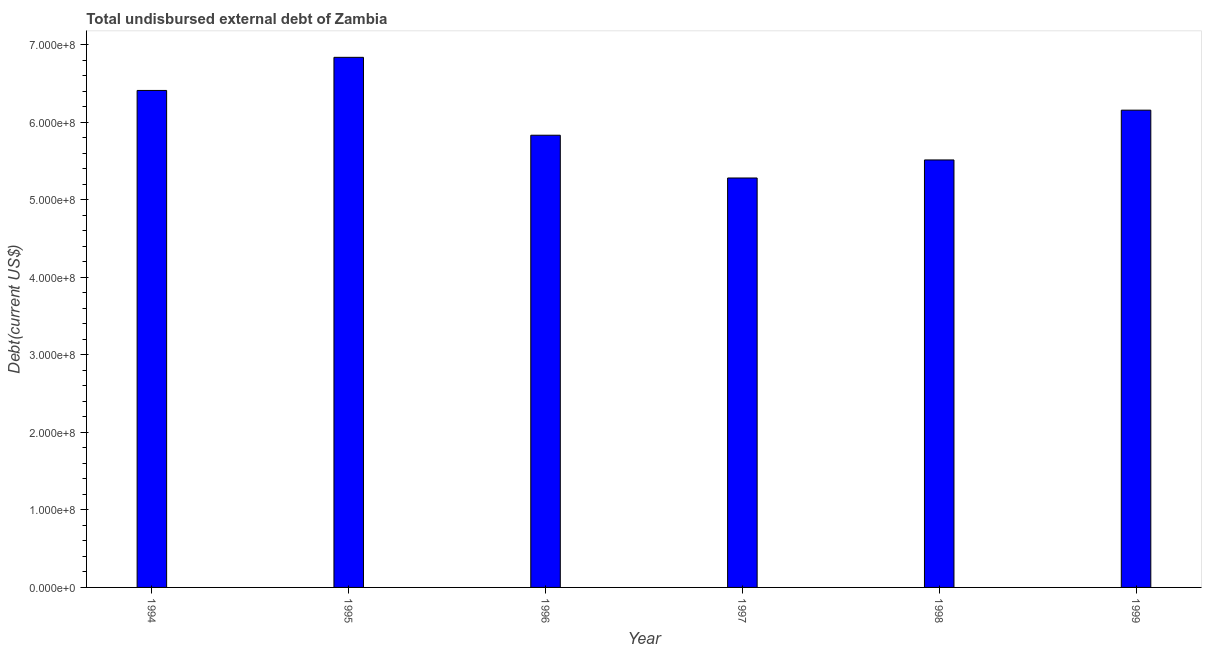Does the graph contain any zero values?
Keep it short and to the point. No. What is the title of the graph?
Make the answer very short. Total undisbursed external debt of Zambia. What is the label or title of the Y-axis?
Provide a succinct answer. Debt(current US$). What is the total debt in 1995?
Offer a very short reply. 6.84e+08. Across all years, what is the maximum total debt?
Offer a very short reply. 6.84e+08. Across all years, what is the minimum total debt?
Your response must be concise. 5.28e+08. In which year was the total debt maximum?
Ensure brevity in your answer.  1995. In which year was the total debt minimum?
Provide a short and direct response. 1997. What is the sum of the total debt?
Offer a terse response. 3.60e+09. What is the difference between the total debt in 1995 and 1998?
Provide a succinct answer. 1.32e+08. What is the average total debt per year?
Provide a succinct answer. 6.01e+08. What is the median total debt?
Your response must be concise. 6.00e+08. In how many years, is the total debt greater than 40000000 US$?
Ensure brevity in your answer.  6. What is the ratio of the total debt in 1997 to that in 1998?
Offer a terse response. 0.96. Is the total debt in 1995 less than that in 1998?
Your response must be concise. No. Is the difference between the total debt in 1995 and 1997 greater than the difference between any two years?
Offer a terse response. Yes. What is the difference between the highest and the second highest total debt?
Offer a terse response. 4.27e+07. What is the difference between the highest and the lowest total debt?
Offer a terse response. 1.56e+08. What is the Debt(current US$) in 1994?
Your answer should be compact. 6.41e+08. What is the Debt(current US$) of 1995?
Your answer should be compact. 6.84e+08. What is the Debt(current US$) of 1996?
Provide a short and direct response. 5.83e+08. What is the Debt(current US$) of 1997?
Your answer should be very brief. 5.28e+08. What is the Debt(current US$) in 1998?
Your answer should be very brief. 5.52e+08. What is the Debt(current US$) in 1999?
Your answer should be very brief. 6.16e+08. What is the difference between the Debt(current US$) in 1994 and 1995?
Offer a terse response. -4.27e+07. What is the difference between the Debt(current US$) in 1994 and 1996?
Offer a terse response. 5.78e+07. What is the difference between the Debt(current US$) in 1994 and 1997?
Your response must be concise. 1.13e+08. What is the difference between the Debt(current US$) in 1994 and 1998?
Ensure brevity in your answer.  8.97e+07. What is the difference between the Debt(current US$) in 1994 and 1999?
Offer a very short reply. 2.54e+07. What is the difference between the Debt(current US$) in 1995 and 1996?
Offer a terse response. 1.01e+08. What is the difference between the Debt(current US$) in 1995 and 1997?
Offer a terse response. 1.56e+08. What is the difference between the Debt(current US$) in 1995 and 1998?
Provide a short and direct response. 1.32e+08. What is the difference between the Debt(current US$) in 1995 and 1999?
Offer a very short reply. 6.82e+07. What is the difference between the Debt(current US$) in 1996 and 1997?
Offer a very short reply. 5.52e+07. What is the difference between the Debt(current US$) in 1996 and 1998?
Your answer should be compact. 3.19e+07. What is the difference between the Debt(current US$) in 1996 and 1999?
Provide a succinct answer. -3.23e+07. What is the difference between the Debt(current US$) in 1997 and 1998?
Your answer should be compact. -2.33e+07. What is the difference between the Debt(current US$) in 1997 and 1999?
Provide a short and direct response. -8.75e+07. What is the difference between the Debt(current US$) in 1998 and 1999?
Your answer should be compact. -6.42e+07. What is the ratio of the Debt(current US$) in 1994 to that in 1995?
Your answer should be very brief. 0.94. What is the ratio of the Debt(current US$) in 1994 to that in 1996?
Give a very brief answer. 1.1. What is the ratio of the Debt(current US$) in 1994 to that in 1997?
Provide a short and direct response. 1.21. What is the ratio of the Debt(current US$) in 1994 to that in 1998?
Give a very brief answer. 1.16. What is the ratio of the Debt(current US$) in 1994 to that in 1999?
Your answer should be compact. 1.04. What is the ratio of the Debt(current US$) in 1995 to that in 1996?
Give a very brief answer. 1.17. What is the ratio of the Debt(current US$) in 1995 to that in 1997?
Make the answer very short. 1.29. What is the ratio of the Debt(current US$) in 1995 to that in 1998?
Provide a short and direct response. 1.24. What is the ratio of the Debt(current US$) in 1995 to that in 1999?
Your answer should be compact. 1.11. What is the ratio of the Debt(current US$) in 1996 to that in 1997?
Ensure brevity in your answer.  1.1. What is the ratio of the Debt(current US$) in 1996 to that in 1998?
Your answer should be compact. 1.06. What is the ratio of the Debt(current US$) in 1996 to that in 1999?
Your answer should be very brief. 0.95. What is the ratio of the Debt(current US$) in 1997 to that in 1998?
Give a very brief answer. 0.96. What is the ratio of the Debt(current US$) in 1997 to that in 1999?
Give a very brief answer. 0.86. What is the ratio of the Debt(current US$) in 1998 to that in 1999?
Provide a short and direct response. 0.9. 